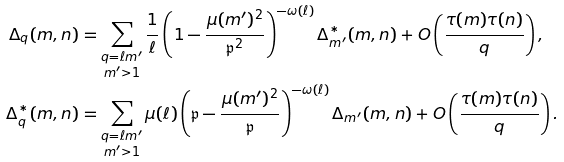<formula> <loc_0><loc_0><loc_500><loc_500>\Delta _ { q } ( m , n ) & = \sum _ { \substack { q = \ell m ^ { \prime } \\ m ^ { \prime } > 1 } } \frac { 1 } { \ell } \left ( 1 - \frac { \mu ( m ^ { \prime } ) ^ { 2 } } { \mathfrak { p } ^ { 2 } } \right ) ^ { - \omega ( \ell ) } \Delta ^ { * } _ { m ^ { \prime } } ( m , n ) + O \left ( \frac { \tau ( m ) \tau ( n ) } { q } \right ) , \\ \Delta ^ { * } _ { q } ( m , n ) & = \sum _ { \substack { q = \ell m ^ { \prime } \\ m ^ { \prime } > 1 } } \mu ( \ell ) \left ( \mathfrak { p } - \frac { \mu ( m ^ { \prime } ) ^ { 2 } } { \mathfrak { p } } \right ) ^ { - \omega ( \ell ) } \Delta _ { m ^ { \prime } } ( m , n ) + O \left ( \frac { \tau ( m ) \tau ( n ) } { q } \right ) .</formula> 